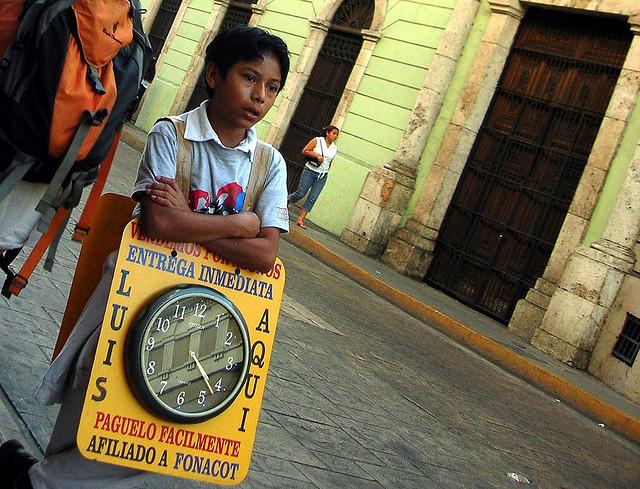What material is the street?
Short answer required. Stone. Is this in America?
Quick response, please. No. What kind of sign is the boy holding?
Give a very brief answer. Clock. 